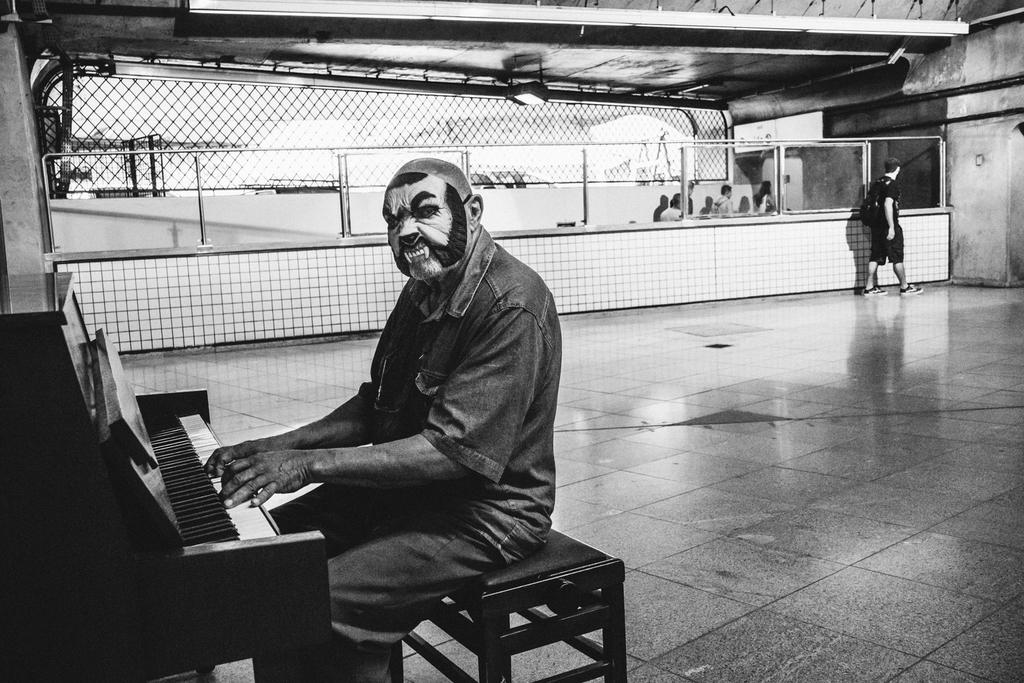What is the person in the image doing? The person is sitting and playing the piano. Can you describe the other people in the image? There is a group of people standing on the floor. How many ladybugs are crawling on the piano keys in the image? There are no ladybugs present in the image; it only features a person playing the piano and a group of people standing on the floor. 